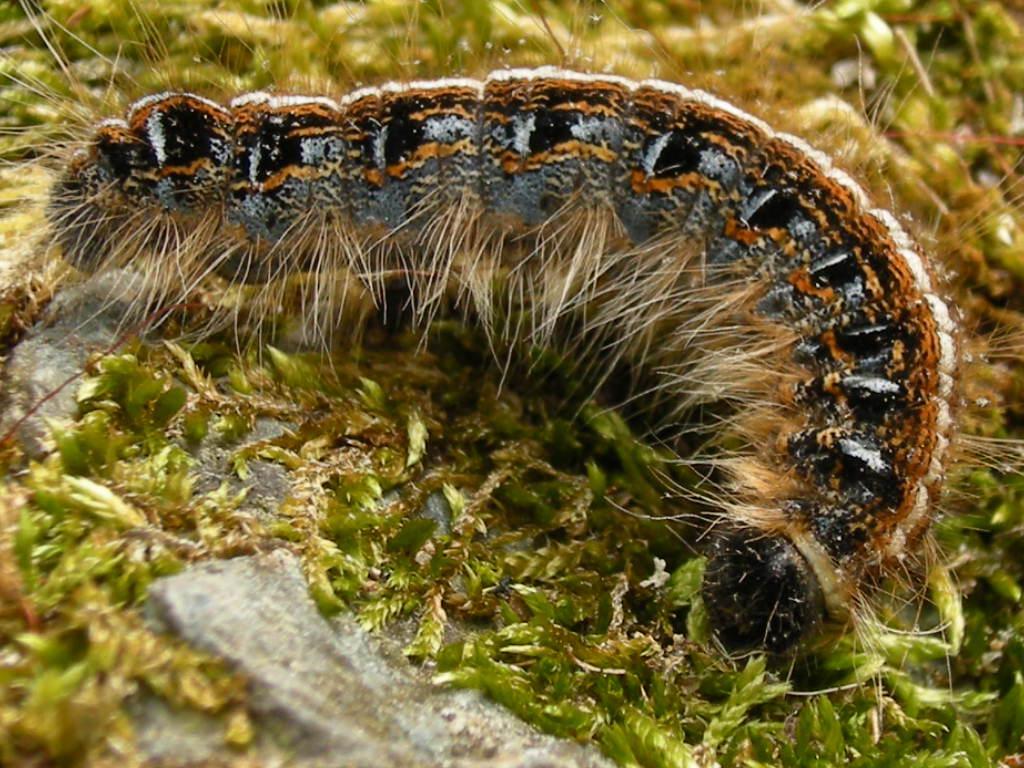Could you give a brief overview of what you see in this image? This image is taken outdoors. At the bottom of the image there is a ground with grass on it. In the middle of the image there is an insect on the ground. 